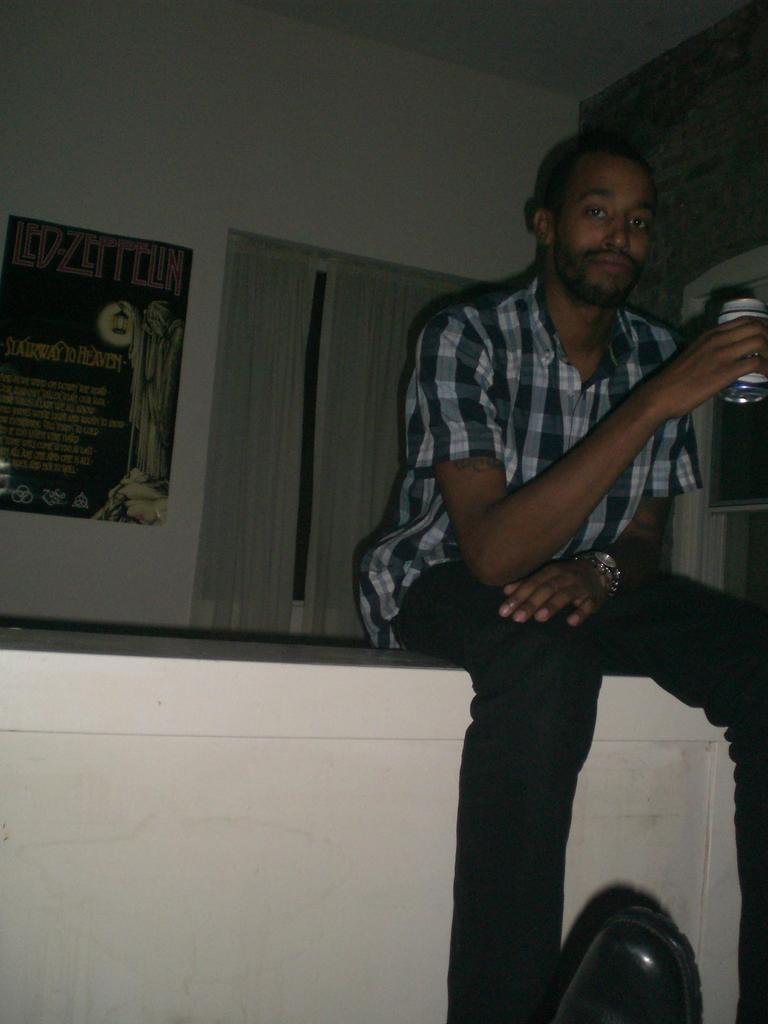What is the position of the man in the image? The man is on the right side of the image and is sitting. What is the man holding in the image? The man is holding a tin in the image. What can be seen on the wall behind the man? There is a poster on the wall behind the man. What type of drink is the man's mother offering him in the image? There is no mention of a drink or the man's mother in the image, so it cannot be determined from the image. 